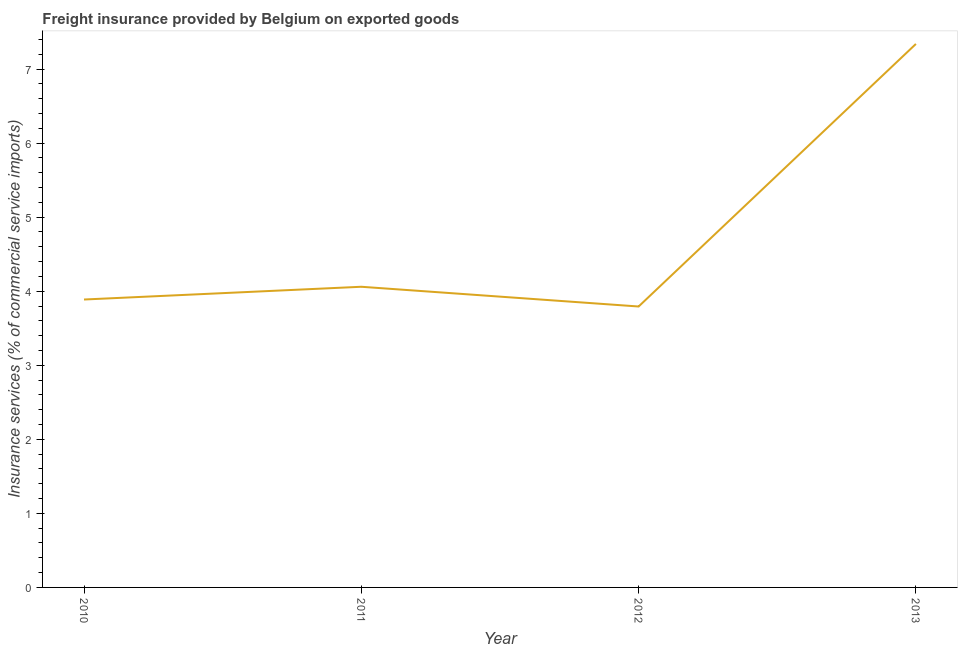What is the freight insurance in 2013?
Your response must be concise. 7.34. Across all years, what is the maximum freight insurance?
Offer a terse response. 7.34. Across all years, what is the minimum freight insurance?
Keep it short and to the point. 3.79. In which year was the freight insurance maximum?
Keep it short and to the point. 2013. What is the sum of the freight insurance?
Ensure brevity in your answer.  19.08. What is the difference between the freight insurance in 2010 and 2011?
Your response must be concise. -0.17. What is the average freight insurance per year?
Your answer should be compact. 4.77. What is the median freight insurance?
Offer a terse response. 3.97. Do a majority of the years between 2013 and 2011 (inclusive) have freight insurance greater than 1.4 %?
Ensure brevity in your answer.  No. What is the ratio of the freight insurance in 2011 to that in 2013?
Provide a short and direct response. 0.55. Is the difference between the freight insurance in 2010 and 2013 greater than the difference between any two years?
Your answer should be compact. No. What is the difference between the highest and the second highest freight insurance?
Your answer should be very brief. 3.28. What is the difference between the highest and the lowest freight insurance?
Your answer should be very brief. 3.55. What is the difference between two consecutive major ticks on the Y-axis?
Ensure brevity in your answer.  1. What is the title of the graph?
Ensure brevity in your answer.  Freight insurance provided by Belgium on exported goods . What is the label or title of the Y-axis?
Your answer should be very brief. Insurance services (% of commercial service imports). What is the Insurance services (% of commercial service imports) in 2010?
Your answer should be very brief. 3.89. What is the Insurance services (% of commercial service imports) of 2011?
Your answer should be very brief. 4.06. What is the Insurance services (% of commercial service imports) in 2012?
Ensure brevity in your answer.  3.79. What is the Insurance services (% of commercial service imports) in 2013?
Give a very brief answer. 7.34. What is the difference between the Insurance services (% of commercial service imports) in 2010 and 2011?
Make the answer very short. -0.17. What is the difference between the Insurance services (% of commercial service imports) in 2010 and 2012?
Provide a short and direct response. 0.09. What is the difference between the Insurance services (% of commercial service imports) in 2010 and 2013?
Provide a succinct answer. -3.45. What is the difference between the Insurance services (% of commercial service imports) in 2011 and 2012?
Give a very brief answer. 0.27. What is the difference between the Insurance services (% of commercial service imports) in 2011 and 2013?
Your answer should be very brief. -3.28. What is the difference between the Insurance services (% of commercial service imports) in 2012 and 2013?
Offer a very short reply. -3.55. What is the ratio of the Insurance services (% of commercial service imports) in 2010 to that in 2011?
Provide a succinct answer. 0.96. What is the ratio of the Insurance services (% of commercial service imports) in 2010 to that in 2012?
Offer a terse response. 1.02. What is the ratio of the Insurance services (% of commercial service imports) in 2010 to that in 2013?
Make the answer very short. 0.53. What is the ratio of the Insurance services (% of commercial service imports) in 2011 to that in 2012?
Make the answer very short. 1.07. What is the ratio of the Insurance services (% of commercial service imports) in 2011 to that in 2013?
Your answer should be very brief. 0.55. What is the ratio of the Insurance services (% of commercial service imports) in 2012 to that in 2013?
Offer a very short reply. 0.52. 